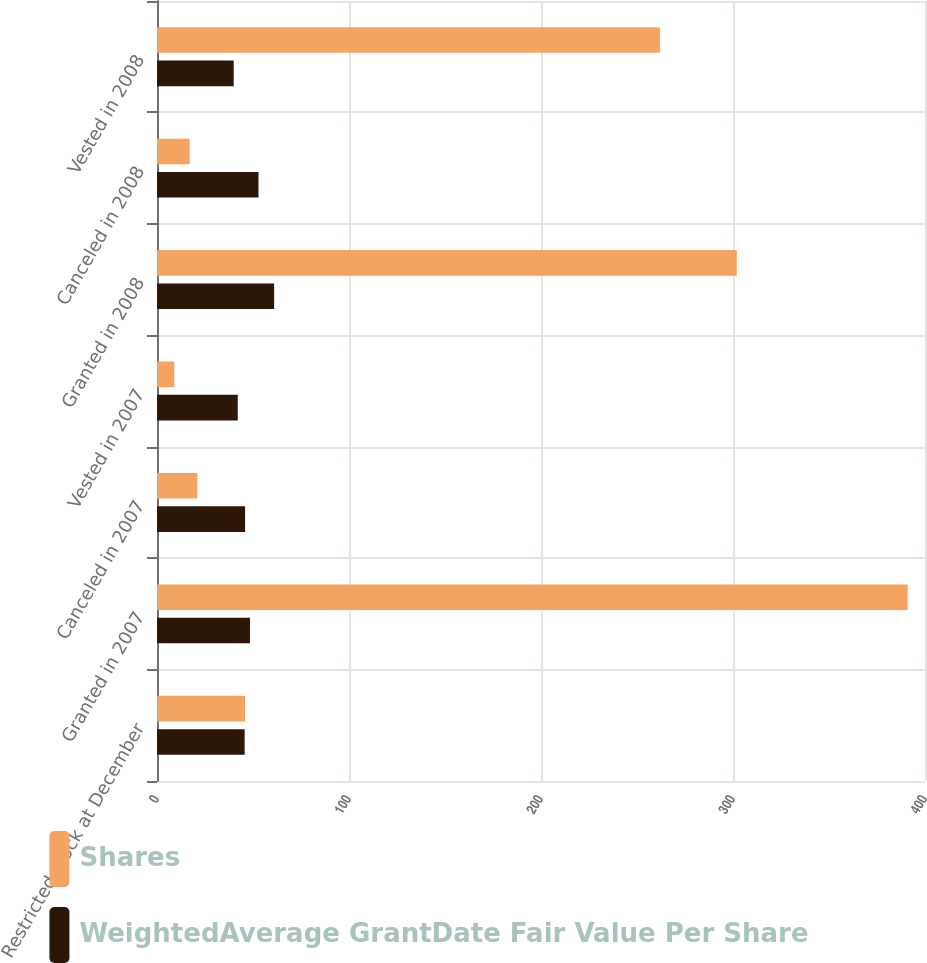Convert chart. <chart><loc_0><loc_0><loc_500><loc_500><stacked_bar_chart><ecel><fcel>Restricted stock at December<fcel>Granted in 2007<fcel>Canceled in 2007<fcel>Vested in 2007<fcel>Granted in 2008<fcel>Canceled in 2008<fcel>Vested in 2008<nl><fcel>Shares<fcel>45.88<fcel>391<fcel>21<fcel>9<fcel>302<fcel>17<fcel>262<nl><fcel>WeightedAverage GrantDate Fair Value Per Share<fcel>45.65<fcel>48.43<fcel>45.88<fcel>42.06<fcel>61<fcel>52.86<fcel>39.95<nl></chart> 